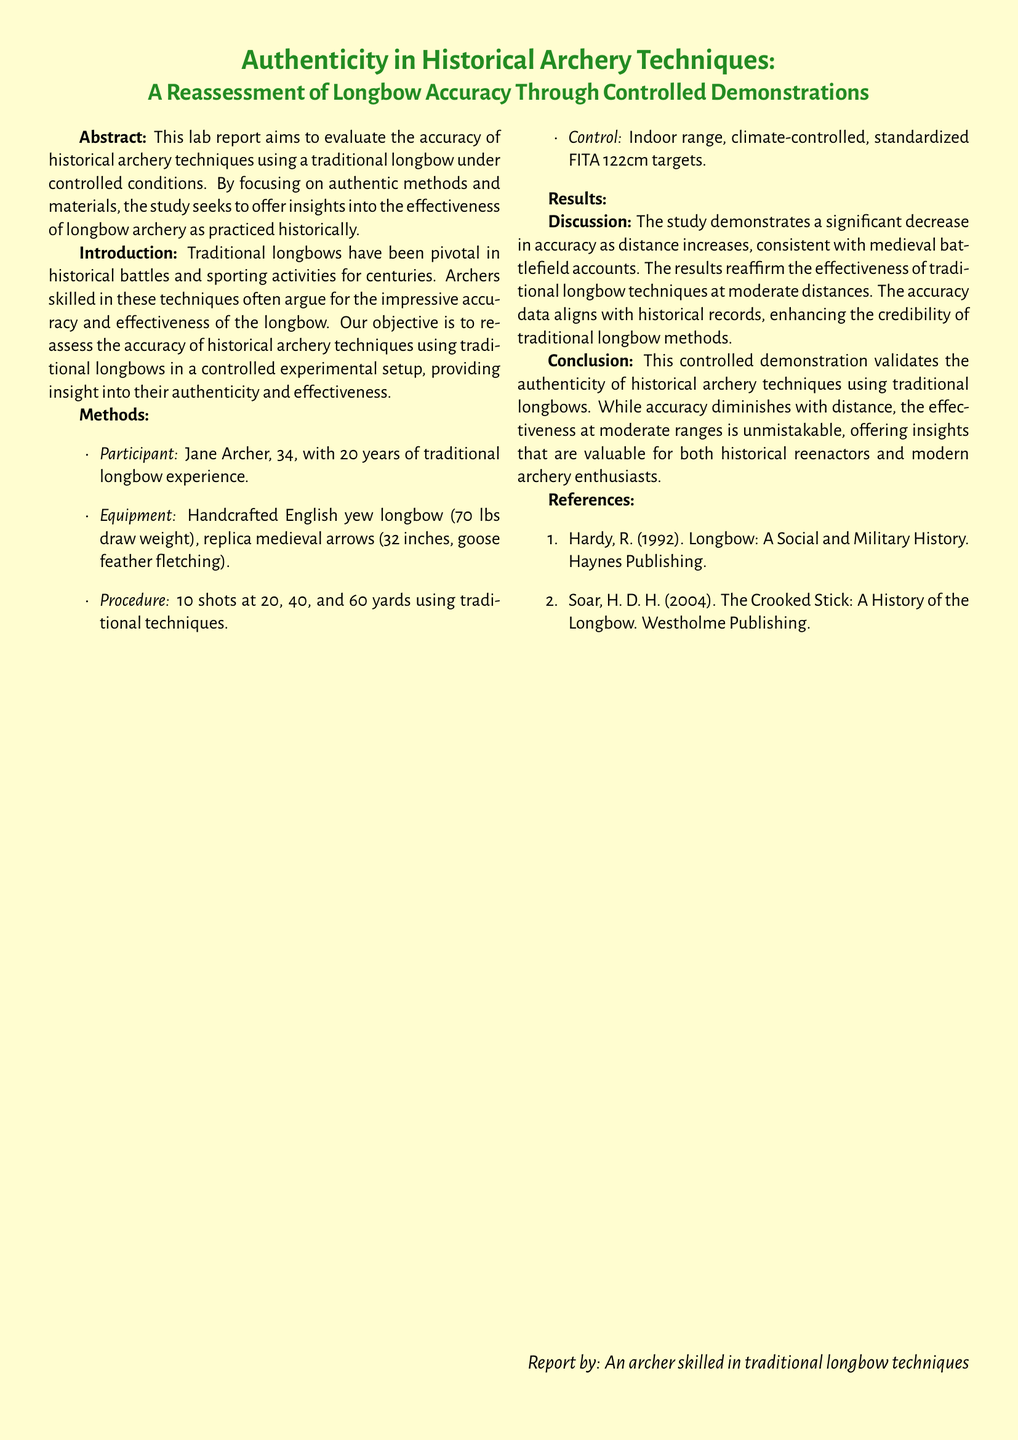What is the main objective of the study? The study aims to evaluate the accuracy of historical archery techniques using a traditional longbow under controlled conditions.
Answer: Evaluate the accuracy Who is the participant in the study? The participant is identified in the methods section, specifically as skilled in traditional longbow experience.
Answer: Jane Archer What is the draw weight of the longbow used? The draw weight is mentioned in the equipment section of the document.
Answer: 70 lbs How many shots were taken at each distance? This information can be found in the procedure part of the methods section.
Answer: 10 shots What is the average deviation at 60 yards? The average deviation is provided in the results table under the column for average deviation at that distance.
Answer: 12 inches What historical documents does this study align with? The findings are compared to historical records evident in the discussion section.
Answer: Medieval battlefield accounts What are the distances used for the archery shots? The distances are listed in the results section of the document, detailing where shots were aimed.
Answer: 20, 40, and 60 yards How many references are cited in the report? The references count can be obtained from the list provided at the end of the document.
Answer: 2 references What type of targets were used in the study? The targets are specified in the methods section, revealing their standardization.
Answer: FITA 122cm targets 